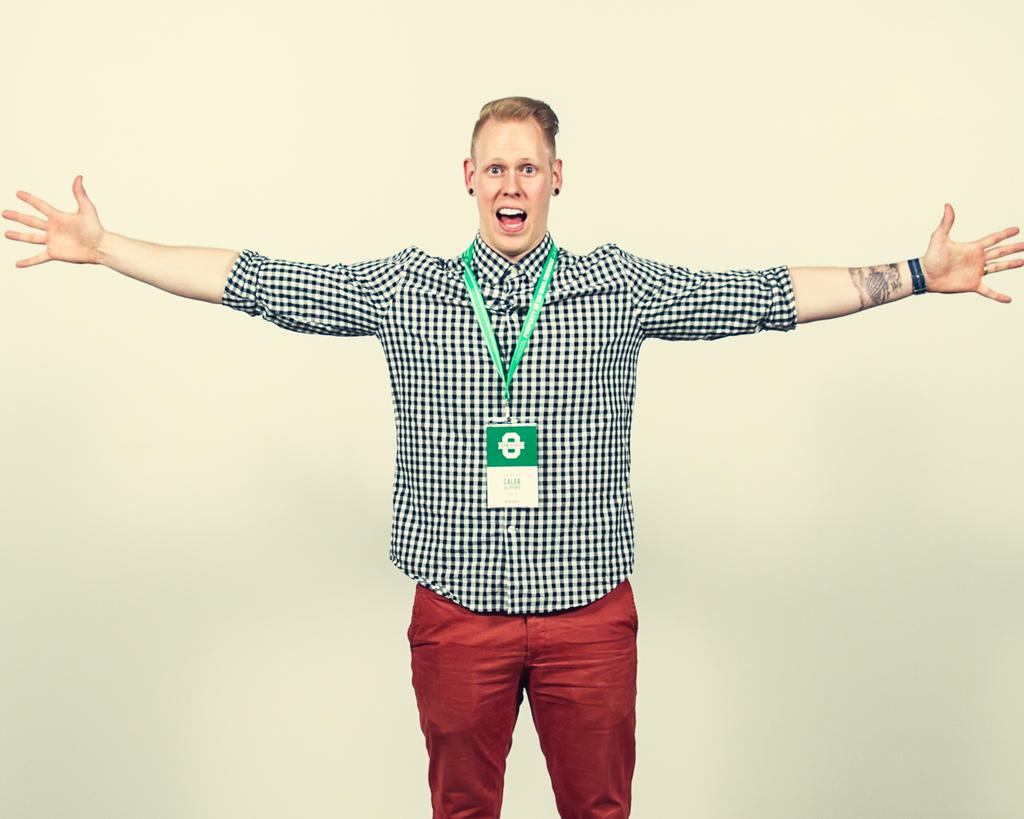What can be seen in the image? There is a person in the image. What is the person wearing? The person is wearing a black and white shirt and red color pants. What is the person doing in the image? The person is standing. What color is the background of the image? The background of the image is cream colored. How many fingers does the person have on their left hand in the image? The image does not show the person's fingers, so it is not possible to determine the number of fingers on their left hand. 